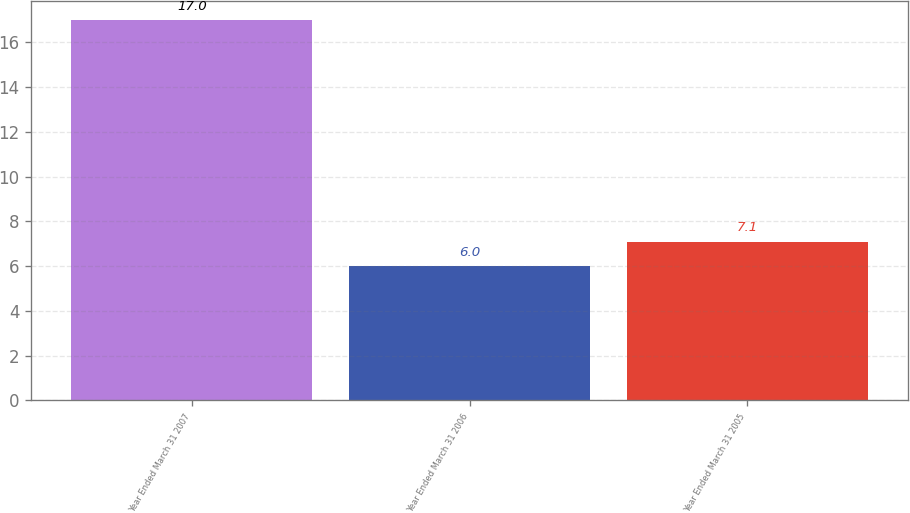Convert chart to OTSL. <chart><loc_0><loc_0><loc_500><loc_500><bar_chart><fcel>Year Ended March 31 2007<fcel>Year Ended March 31 2006<fcel>Year Ended March 31 2005<nl><fcel>17<fcel>6<fcel>7.1<nl></chart> 